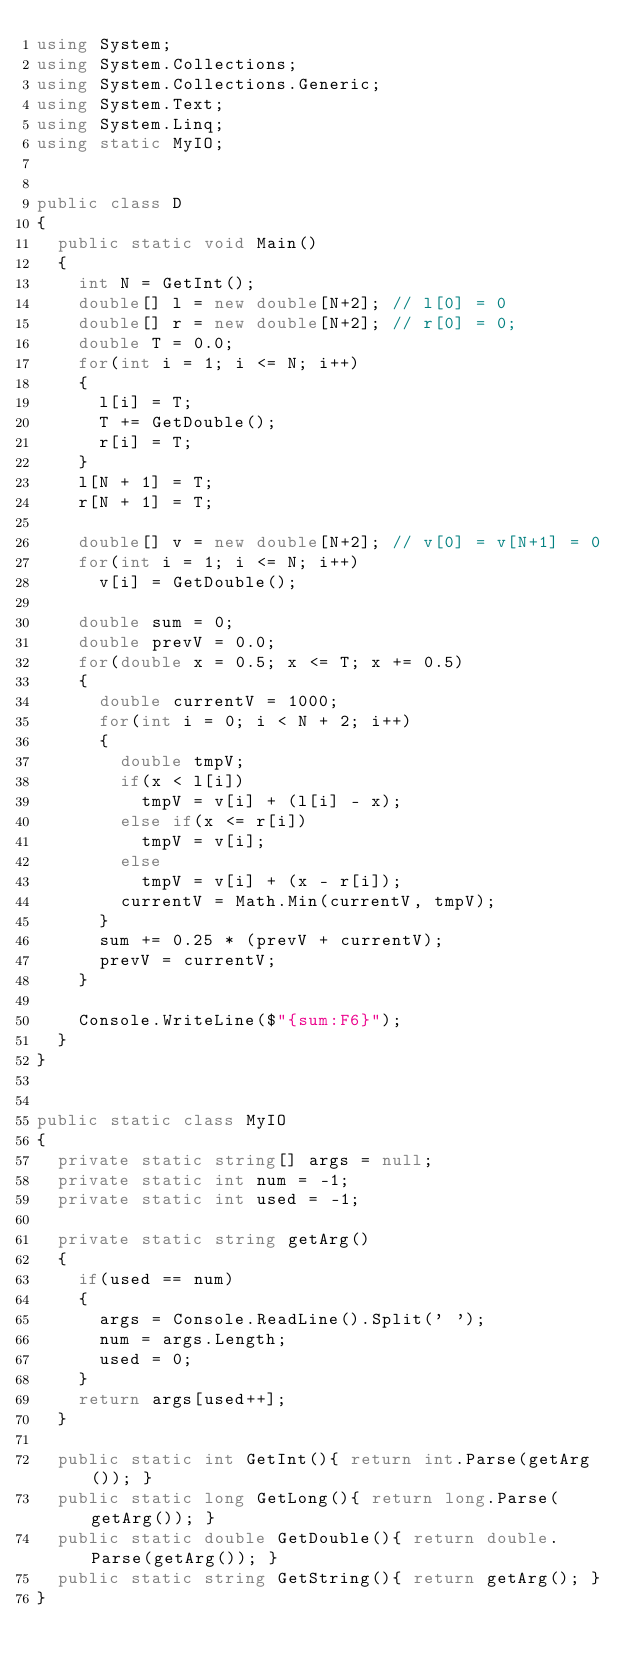Convert code to text. <code><loc_0><loc_0><loc_500><loc_500><_C#_>using System;
using System.Collections;
using System.Collections.Generic;
using System.Text;
using System.Linq;
using static MyIO;


public class D
{
	public static void Main()
	{
		int N = GetInt();
		double[] l = new double[N+2];	// l[0] = 0
		double[] r = new double[N+2];	// r[0] = 0;
		double T = 0.0;
		for(int i = 1; i <= N; i++)
		{
			l[i] = T;
			T += GetDouble();
			r[i] = T;
		}
		l[N + 1] = T;
		r[N + 1] = T;

		double[] v = new double[N+2];	// v[0] = v[N+1] = 0
		for(int i = 1; i <= N; i++)
			v[i] = GetDouble();

		double sum = 0;		
		double prevV = 0.0;
		for(double x = 0.5; x <= T; x += 0.5)
		{
			double currentV = 1000;
			for(int i = 0; i < N + 2; i++)
			{
				double tmpV;
				if(x < l[i])
					tmpV = v[i] + (l[i] - x);
				else if(x <= r[i])
					tmpV = v[i];
				else
					tmpV = v[i] + (x - r[i]);
				currentV = Math.Min(currentV, tmpV);
			}
			sum += 0.25 * (prevV + currentV);
			prevV = currentV;
		}

		Console.WriteLine($"{sum:F6}");
	}
}


public static class MyIO
{
	private static string[] args = null;
	private static int num = -1;
	private static int used = -1;

	private static string getArg()
	{
		if(used == num)
		{
			args = Console.ReadLine().Split(' ');
			num = args.Length;
			used = 0;
		}
		return args[used++];
	}

	public static int GetInt(){ return int.Parse(getArg()); }
	public static long GetLong(){ return long.Parse(getArg()); }
	public static double GetDouble(){ return double.Parse(getArg()); }
	public static string GetString(){ return getArg(); }
}</code> 